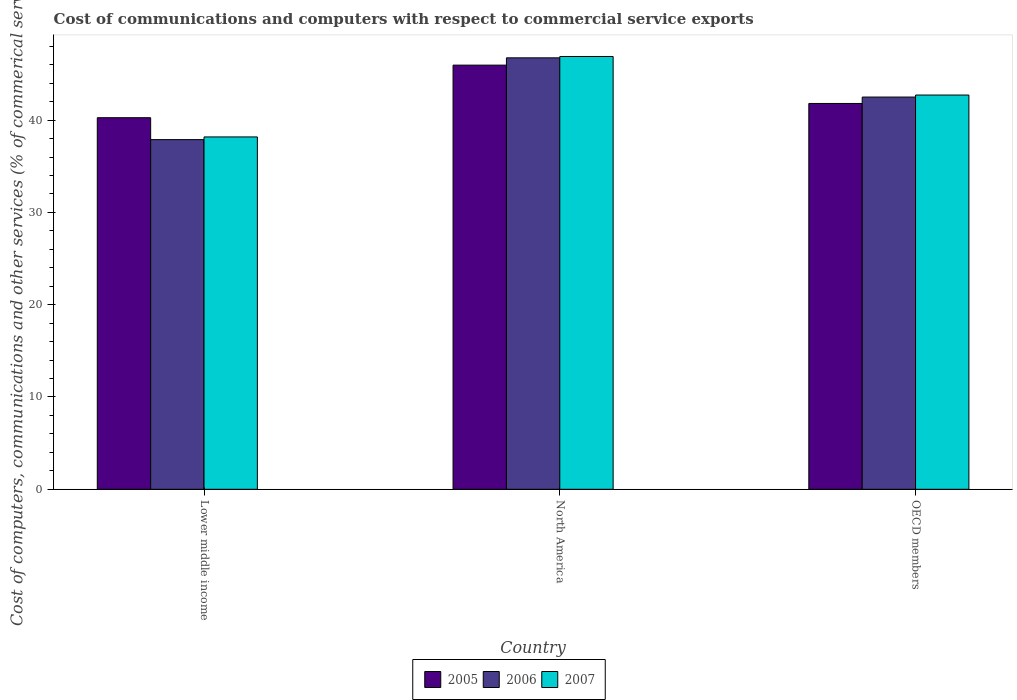How many different coloured bars are there?
Offer a very short reply. 3. Are the number of bars on each tick of the X-axis equal?
Ensure brevity in your answer.  Yes. How many bars are there on the 3rd tick from the left?
Offer a very short reply. 3. What is the cost of communications and computers in 2005 in North America?
Provide a succinct answer. 45.96. Across all countries, what is the maximum cost of communications and computers in 2007?
Provide a succinct answer. 46.89. Across all countries, what is the minimum cost of communications and computers in 2006?
Ensure brevity in your answer.  37.89. In which country was the cost of communications and computers in 2005 minimum?
Your answer should be very brief. Lower middle income. What is the total cost of communications and computers in 2007 in the graph?
Make the answer very short. 127.78. What is the difference between the cost of communications and computers in 2005 in North America and that in OECD members?
Your answer should be compact. 4.15. What is the difference between the cost of communications and computers in 2007 in OECD members and the cost of communications and computers in 2005 in Lower middle income?
Offer a terse response. 2.46. What is the average cost of communications and computers in 2005 per country?
Make the answer very short. 42.67. What is the difference between the cost of communications and computers of/in 2006 and cost of communications and computers of/in 2007 in OECD members?
Your answer should be compact. -0.22. In how many countries, is the cost of communications and computers in 2005 greater than 26 %?
Make the answer very short. 3. What is the ratio of the cost of communications and computers in 2006 in Lower middle income to that in OECD members?
Offer a very short reply. 0.89. Is the difference between the cost of communications and computers in 2006 in North America and OECD members greater than the difference between the cost of communications and computers in 2007 in North America and OECD members?
Keep it short and to the point. Yes. What is the difference between the highest and the second highest cost of communications and computers in 2006?
Keep it short and to the point. 4.61. What is the difference between the highest and the lowest cost of communications and computers in 2006?
Provide a short and direct response. 8.86. What does the 2nd bar from the left in OECD members represents?
Make the answer very short. 2006. How many bars are there?
Your answer should be compact. 9. Are all the bars in the graph horizontal?
Offer a terse response. No. How many countries are there in the graph?
Your response must be concise. 3. What is the difference between two consecutive major ticks on the Y-axis?
Your answer should be compact. 10. Does the graph contain grids?
Your response must be concise. No. Where does the legend appear in the graph?
Provide a short and direct response. Bottom center. How many legend labels are there?
Your answer should be compact. 3. How are the legend labels stacked?
Provide a succinct answer. Horizontal. What is the title of the graph?
Provide a succinct answer. Cost of communications and computers with respect to commercial service exports. What is the label or title of the Y-axis?
Ensure brevity in your answer.  Cost of computers, communications and other services (% of commerical service exports). What is the Cost of computers, communications and other services (% of commerical service exports) in 2005 in Lower middle income?
Give a very brief answer. 40.26. What is the Cost of computers, communications and other services (% of commerical service exports) of 2006 in Lower middle income?
Provide a short and direct response. 37.89. What is the Cost of computers, communications and other services (% of commerical service exports) in 2007 in Lower middle income?
Provide a succinct answer. 38.18. What is the Cost of computers, communications and other services (% of commerical service exports) in 2005 in North America?
Your response must be concise. 45.96. What is the Cost of computers, communications and other services (% of commerical service exports) in 2006 in North America?
Offer a terse response. 46.75. What is the Cost of computers, communications and other services (% of commerical service exports) of 2007 in North America?
Provide a short and direct response. 46.89. What is the Cost of computers, communications and other services (% of commerical service exports) in 2005 in OECD members?
Ensure brevity in your answer.  41.8. What is the Cost of computers, communications and other services (% of commerical service exports) of 2006 in OECD members?
Give a very brief answer. 42.5. What is the Cost of computers, communications and other services (% of commerical service exports) of 2007 in OECD members?
Give a very brief answer. 42.72. Across all countries, what is the maximum Cost of computers, communications and other services (% of commerical service exports) of 2005?
Your answer should be compact. 45.96. Across all countries, what is the maximum Cost of computers, communications and other services (% of commerical service exports) of 2006?
Your answer should be compact. 46.75. Across all countries, what is the maximum Cost of computers, communications and other services (% of commerical service exports) of 2007?
Give a very brief answer. 46.89. Across all countries, what is the minimum Cost of computers, communications and other services (% of commerical service exports) of 2005?
Offer a very short reply. 40.26. Across all countries, what is the minimum Cost of computers, communications and other services (% of commerical service exports) of 2006?
Your response must be concise. 37.89. Across all countries, what is the minimum Cost of computers, communications and other services (% of commerical service exports) of 2007?
Provide a short and direct response. 38.18. What is the total Cost of computers, communications and other services (% of commerical service exports) of 2005 in the graph?
Offer a terse response. 128.02. What is the total Cost of computers, communications and other services (% of commerical service exports) of 2006 in the graph?
Keep it short and to the point. 127.13. What is the total Cost of computers, communications and other services (% of commerical service exports) in 2007 in the graph?
Offer a very short reply. 127.78. What is the difference between the Cost of computers, communications and other services (% of commerical service exports) of 2005 in Lower middle income and that in North America?
Your answer should be compact. -5.7. What is the difference between the Cost of computers, communications and other services (% of commerical service exports) of 2006 in Lower middle income and that in North America?
Make the answer very short. -8.86. What is the difference between the Cost of computers, communications and other services (% of commerical service exports) in 2007 in Lower middle income and that in North America?
Make the answer very short. -8.71. What is the difference between the Cost of computers, communications and other services (% of commerical service exports) of 2005 in Lower middle income and that in OECD members?
Offer a terse response. -1.54. What is the difference between the Cost of computers, communications and other services (% of commerical service exports) of 2006 in Lower middle income and that in OECD members?
Your answer should be very brief. -4.61. What is the difference between the Cost of computers, communications and other services (% of commerical service exports) of 2007 in Lower middle income and that in OECD members?
Offer a very short reply. -4.54. What is the difference between the Cost of computers, communications and other services (% of commerical service exports) of 2005 in North America and that in OECD members?
Make the answer very short. 4.15. What is the difference between the Cost of computers, communications and other services (% of commerical service exports) of 2006 in North America and that in OECD members?
Offer a terse response. 4.25. What is the difference between the Cost of computers, communications and other services (% of commerical service exports) in 2007 in North America and that in OECD members?
Your answer should be compact. 4.17. What is the difference between the Cost of computers, communications and other services (% of commerical service exports) in 2005 in Lower middle income and the Cost of computers, communications and other services (% of commerical service exports) in 2006 in North America?
Offer a terse response. -6.49. What is the difference between the Cost of computers, communications and other services (% of commerical service exports) in 2005 in Lower middle income and the Cost of computers, communications and other services (% of commerical service exports) in 2007 in North America?
Your answer should be compact. -6.63. What is the difference between the Cost of computers, communications and other services (% of commerical service exports) in 2006 in Lower middle income and the Cost of computers, communications and other services (% of commerical service exports) in 2007 in North America?
Your response must be concise. -9. What is the difference between the Cost of computers, communications and other services (% of commerical service exports) of 2005 in Lower middle income and the Cost of computers, communications and other services (% of commerical service exports) of 2006 in OECD members?
Your answer should be compact. -2.24. What is the difference between the Cost of computers, communications and other services (% of commerical service exports) of 2005 in Lower middle income and the Cost of computers, communications and other services (% of commerical service exports) of 2007 in OECD members?
Offer a terse response. -2.46. What is the difference between the Cost of computers, communications and other services (% of commerical service exports) in 2006 in Lower middle income and the Cost of computers, communications and other services (% of commerical service exports) in 2007 in OECD members?
Ensure brevity in your answer.  -4.83. What is the difference between the Cost of computers, communications and other services (% of commerical service exports) of 2005 in North America and the Cost of computers, communications and other services (% of commerical service exports) of 2006 in OECD members?
Keep it short and to the point. 3.46. What is the difference between the Cost of computers, communications and other services (% of commerical service exports) in 2005 in North America and the Cost of computers, communications and other services (% of commerical service exports) in 2007 in OECD members?
Offer a terse response. 3.24. What is the difference between the Cost of computers, communications and other services (% of commerical service exports) in 2006 in North America and the Cost of computers, communications and other services (% of commerical service exports) in 2007 in OECD members?
Provide a succinct answer. 4.03. What is the average Cost of computers, communications and other services (% of commerical service exports) in 2005 per country?
Give a very brief answer. 42.67. What is the average Cost of computers, communications and other services (% of commerical service exports) in 2006 per country?
Provide a succinct answer. 42.38. What is the average Cost of computers, communications and other services (% of commerical service exports) in 2007 per country?
Your answer should be compact. 42.59. What is the difference between the Cost of computers, communications and other services (% of commerical service exports) of 2005 and Cost of computers, communications and other services (% of commerical service exports) of 2006 in Lower middle income?
Your answer should be very brief. 2.37. What is the difference between the Cost of computers, communications and other services (% of commerical service exports) of 2005 and Cost of computers, communications and other services (% of commerical service exports) of 2007 in Lower middle income?
Provide a succinct answer. 2.08. What is the difference between the Cost of computers, communications and other services (% of commerical service exports) in 2006 and Cost of computers, communications and other services (% of commerical service exports) in 2007 in Lower middle income?
Keep it short and to the point. -0.29. What is the difference between the Cost of computers, communications and other services (% of commerical service exports) of 2005 and Cost of computers, communications and other services (% of commerical service exports) of 2006 in North America?
Provide a short and direct response. -0.79. What is the difference between the Cost of computers, communications and other services (% of commerical service exports) in 2005 and Cost of computers, communications and other services (% of commerical service exports) in 2007 in North America?
Provide a short and direct response. -0.93. What is the difference between the Cost of computers, communications and other services (% of commerical service exports) of 2006 and Cost of computers, communications and other services (% of commerical service exports) of 2007 in North America?
Keep it short and to the point. -0.14. What is the difference between the Cost of computers, communications and other services (% of commerical service exports) of 2005 and Cost of computers, communications and other services (% of commerical service exports) of 2006 in OECD members?
Provide a succinct answer. -0.69. What is the difference between the Cost of computers, communications and other services (% of commerical service exports) of 2005 and Cost of computers, communications and other services (% of commerical service exports) of 2007 in OECD members?
Provide a succinct answer. -0.91. What is the difference between the Cost of computers, communications and other services (% of commerical service exports) of 2006 and Cost of computers, communications and other services (% of commerical service exports) of 2007 in OECD members?
Your answer should be very brief. -0.22. What is the ratio of the Cost of computers, communications and other services (% of commerical service exports) of 2005 in Lower middle income to that in North America?
Provide a short and direct response. 0.88. What is the ratio of the Cost of computers, communications and other services (% of commerical service exports) of 2006 in Lower middle income to that in North America?
Provide a short and direct response. 0.81. What is the ratio of the Cost of computers, communications and other services (% of commerical service exports) of 2007 in Lower middle income to that in North America?
Provide a short and direct response. 0.81. What is the ratio of the Cost of computers, communications and other services (% of commerical service exports) of 2006 in Lower middle income to that in OECD members?
Keep it short and to the point. 0.89. What is the ratio of the Cost of computers, communications and other services (% of commerical service exports) of 2007 in Lower middle income to that in OECD members?
Keep it short and to the point. 0.89. What is the ratio of the Cost of computers, communications and other services (% of commerical service exports) in 2005 in North America to that in OECD members?
Keep it short and to the point. 1.1. What is the ratio of the Cost of computers, communications and other services (% of commerical service exports) in 2006 in North America to that in OECD members?
Offer a very short reply. 1.1. What is the ratio of the Cost of computers, communications and other services (% of commerical service exports) in 2007 in North America to that in OECD members?
Make the answer very short. 1.1. What is the difference between the highest and the second highest Cost of computers, communications and other services (% of commerical service exports) in 2005?
Keep it short and to the point. 4.15. What is the difference between the highest and the second highest Cost of computers, communications and other services (% of commerical service exports) of 2006?
Your answer should be compact. 4.25. What is the difference between the highest and the second highest Cost of computers, communications and other services (% of commerical service exports) of 2007?
Your answer should be compact. 4.17. What is the difference between the highest and the lowest Cost of computers, communications and other services (% of commerical service exports) of 2005?
Your answer should be compact. 5.7. What is the difference between the highest and the lowest Cost of computers, communications and other services (% of commerical service exports) in 2006?
Provide a short and direct response. 8.86. What is the difference between the highest and the lowest Cost of computers, communications and other services (% of commerical service exports) of 2007?
Offer a terse response. 8.71. 